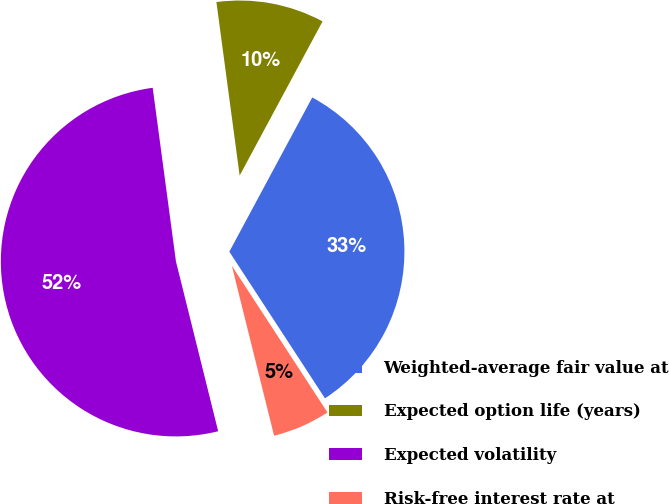Convert chart to OTSL. <chart><loc_0><loc_0><loc_500><loc_500><pie_chart><fcel>Weighted-average fair value at<fcel>Expected option life (years)<fcel>Expected volatility<fcel>Risk-free interest rate at<nl><fcel>32.95%<fcel>9.97%<fcel>51.76%<fcel>5.32%<nl></chart> 